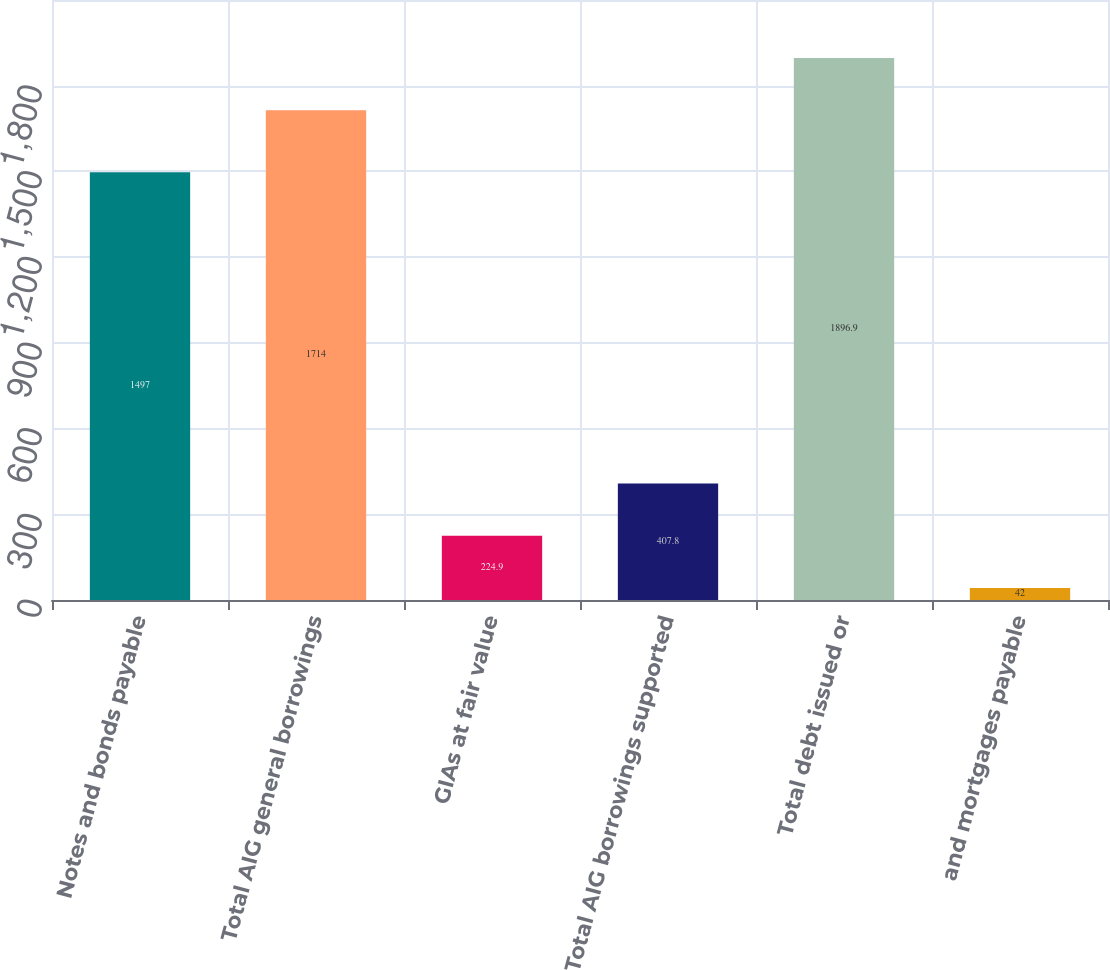Convert chart. <chart><loc_0><loc_0><loc_500><loc_500><bar_chart><fcel>Notes and bonds payable<fcel>Total AIG general borrowings<fcel>GIAs at fair value<fcel>Total AIG borrowings supported<fcel>Total debt issued or<fcel>and mortgages payable<nl><fcel>1497<fcel>1714<fcel>224.9<fcel>407.8<fcel>1896.9<fcel>42<nl></chart> 